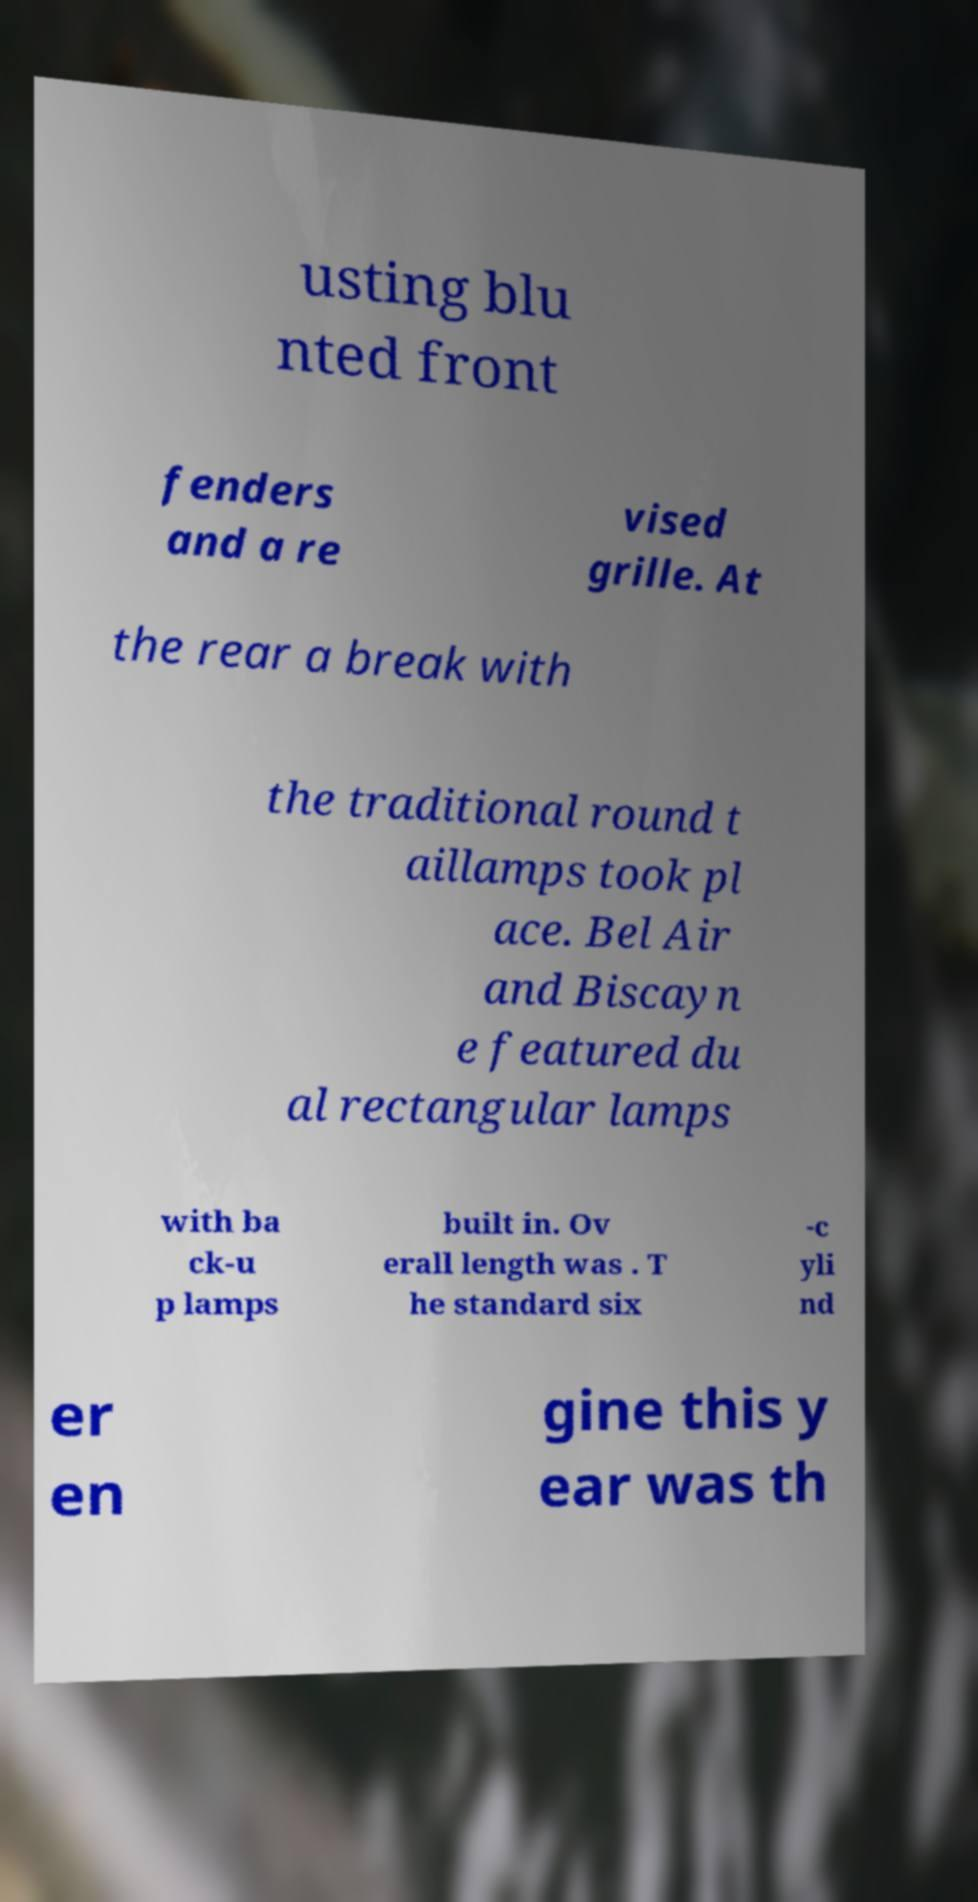For documentation purposes, I need the text within this image transcribed. Could you provide that? usting blu nted front fenders and a re vised grille. At the rear a break with the traditional round t aillamps took pl ace. Bel Air and Biscayn e featured du al rectangular lamps with ba ck-u p lamps built in. Ov erall length was . T he standard six -c yli nd er en gine this y ear was th 